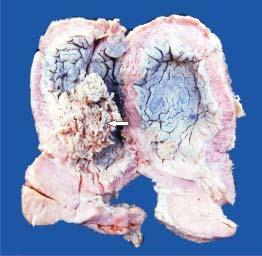what does the mucosal surface show?
Answer the question using a single word or phrase. Papillary tumour floating in the lumen 